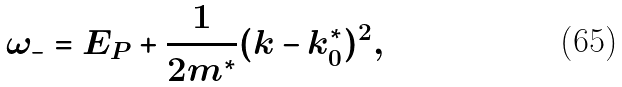<formula> <loc_0><loc_0><loc_500><loc_500>\omega _ { - } = E _ { P } + \frac { 1 } { 2 m ^ { * } } ( k - k _ { 0 } ^ { * } ) ^ { 2 } ,</formula> 